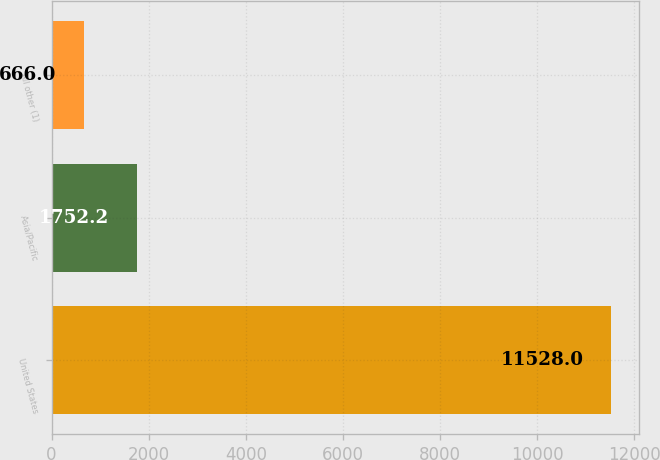Convert chart. <chart><loc_0><loc_0><loc_500><loc_500><bar_chart><fcel>United States<fcel>Asia/Pacific<fcel>All other (1)<nl><fcel>11528<fcel>1752.2<fcel>666<nl></chart> 